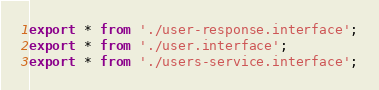Convert code to text. <code><loc_0><loc_0><loc_500><loc_500><_TypeScript_>export * from './user-response.interface';
export * from './user.interface';
export * from './users-service.interface';
</code> 